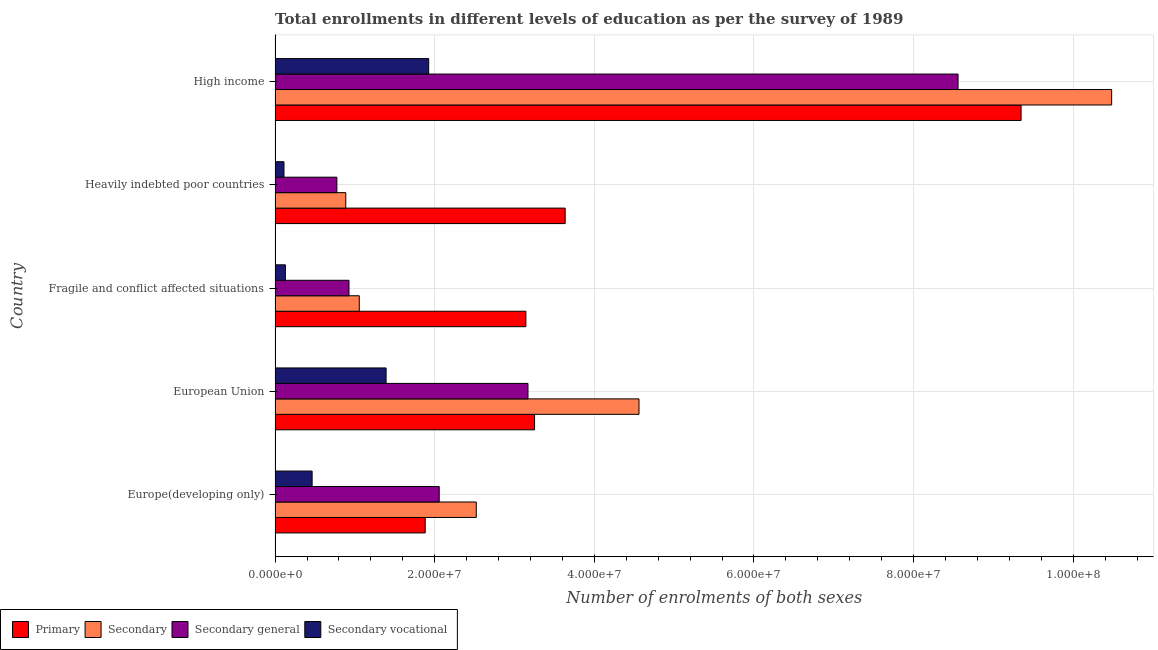How many different coloured bars are there?
Offer a terse response. 4. How many groups of bars are there?
Ensure brevity in your answer.  5. Are the number of bars on each tick of the Y-axis equal?
Keep it short and to the point. Yes. How many bars are there on the 4th tick from the top?
Your response must be concise. 4. How many bars are there on the 2nd tick from the bottom?
Ensure brevity in your answer.  4. What is the label of the 4th group of bars from the top?
Provide a short and direct response. European Union. In how many cases, is the number of bars for a given country not equal to the number of legend labels?
Give a very brief answer. 0. What is the number of enrolments in primary education in European Union?
Your response must be concise. 3.25e+07. Across all countries, what is the maximum number of enrolments in secondary education?
Ensure brevity in your answer.  1.05e+08. Across all countries, what is the minimum number of enrolments in secondary vocational education?
Your response must be concise. 1.12e+06. In which country was the number of enrolments in secondary general education maximum?
Give a very brief answer. High income. In which country was the number of enrolments in secondary education minimum?
Offer a very short reply. Heavily indebted poor countries. What is the total number of enrolments in secondary vocational education in the graph?
Give a very brief answer. 4.02e+07. What is the difference between the number of enrolments in secondary education in Europe(developing only) and that in High income?
Offer a very short reply. -7.96e+07. What is the difference between the number of enrolments in secondary general education in Heavily indebted poor countries and the number of enrolments in secondary education in European Union?
Make the answer very short. -3.79e+07. What is the average number of enrolments in primary education per country?
Your response must be concise. 4.25e+07. What is the difference between the number of enrolments in secondary vocational education and number of enrolments in secondary general education in Fragile and conflict affected situations?
Your response must be concise. -7.97e+06. In how many countries, is the number of enrolments in primary education greater than 84000000 ?
Ensure brevity in your answer.  1. What is the ratio of the number of enrolments in secondary education in Europe(developing only) to that in Heavily indebted poor countries?
Ensure brevity in your answer.  2.85. Is the number of enrolments in secondary vocational education in Fragile and conflict affected situations less than that in High income?
Keep it short and to the point. Yes. Is the difference between the number of enrolments in secondary general education in Europe(developing only) and Fragile and conflict affected situations greater than the difference between the number of enrolments in primary education in Europe(developing only) and Fragile and conflict affected situations?
Keep it short and to the point. Yes. What is the difference between the highest and the second highest number of enrolments in secondary general education?
Ensure brevity in your answer.  5.39e+07. What is the difference between the highest and the lowest number of enrolments in secondary general education?
Provide a succinct answer. 7.78e+07. Is the sum of the number of enrolments in primary education in Europe(developing only) and Heavily indebted poor countries greater than the maximum number of enrolments in secondary vocational education across all countries?
Your response must be concise. Yes. What does the 1st bar from the top in High income represents?
Ensure brevity in your answer.  Secondary vocational. What does the 3rd bar from the bottom in Europe(developing only) represents?
Provide a succinct answer. Secondary general. How many bars are there?
Give a very brief answer. 20. How many countries are there in the graph?
Your answer should be very brief. 5. Are the values on the major ticks of X-axis written in scientific E-notation?
Offer a terse response. Yes. Does the graph contain any zero values?
Offer a very short reply. No. How many legend labels are there?
Provide a succinct answer. 4. What is the title of the graph?
Your answer should be very brief. Total enrollments in different levels of education as per the survey of 1989. Does "Overall level" appear as one of the legend labels in the graph?
Keep it short and to the point. No. What is the label or title of the X-axis?
Your answer should be very brief. Number of enrolments of both sexes. What is the Number of enrolments of both sexes in Primary in Europe(developing only)?
Offer a very short reply. 1.88e+07. What is the Number of enrolments of both sexes of Secondary in Europe(developing only)?
Offer a very short reply. 2.52e+07. What is the Number of enrolments of both sexes of Secondary general in Europe(developing only)?
Give a very brief answer. 2.06e+07. What is the Number of enrolments of both sexes of Secondary vocational in Europe(developing only)?
Keep it short and to the point. 4.64e+06. What is the Number of enrolments of both sexes of Primary in European Union?
Keep it short and to the point. 3.25e+07. What is the Number of enrolments of both sexes in Secondary in European Union?
Make the answer very short. 4.56e+07. What is the Number of enrolments of both sexes in Secondary general in European Union?
Your answer should be very brief. 3.17e+07. What is the Number of enrolments of both sexes of Secondary vocational in European Union?
Your response must be concise. 1.39e+07. What is the Number of enrolments of both sexes of Primary in Fragile and conflict affected situations?
Your answer should be very brief. 3.14e+07. What is the Number of enrolments of both sexes of Secondary in Fragile and conflict affected situations?
Make the answer very short. 1.06e+07. What is the Number of enrolments of both sexes in Secondary general in Fragile and conflict affected situations?
Your answer should be very brief. 9.26e+06. What is the Number of enrolments of both sexes in Secondary vocational in Fragile and conflict affected situations?
Ensure brevity in your answer.  1.29e+06. What is the Number of enrolments of both sexes in Primary in Heavily indebted poor countries?
Offer a very short reply. 3.63e+07. What is the Number of enrolments of both sexes of Secondary in Heavily indebted poor countries?
Make the answer very short. 8.86e+06. What is the Number of enrolments of both sexes in Secondary general in Heavily indebted poor countries?
Provide a short and direct response. 7.74e+06. What is the Number of enrolments of both sexes in Secondary vocational in Heavily indebted poor countries?
Your answer should be compact. 1.12e+06. What is the Number of enrolments of both sexes in Primary in High income?
Provide a succinct answer. 9.35e+07. What is the Number of enrolments of both sexes in Secondary in High income?
Make the answer very short. 1.05e+08. What is the Number of enrolments of both sexes of Secondary general in High income?
Provide a short and direct response. 8.56e+07. What is the Number of enrolments of both sexes in Secondary vocational in High income?
Ensure brevity in your answer.  1.92e+07. Across all countries, what is the maximum Number of enrolments of both sexes of Primary?
Your answer should be very brief. 9.35e+07. Across all countries, what is the maximum Number of enrolments of both sexes in Secondary?
Your answer should be very brief. 1.05e+08. Across all countries, what is the maximum Number of enrolments of both sexes of Secondary general?
Ensure brevity in your answer.  8.56e+07. Across all countries, what is the maximum Number of enrolments of both sexes of Secondary vocational?
Offer a very short reply. 1.92e+07. Across all countries, what is the minimum Number of enrolments of both sexes in Primary?
Provide a short and direct response. 1.88e+07. Across all countries, what is the minimum Number of enrolments of both sexes of Secondary?
Offer a terse response. 8.86e+06. Across all countries, what is the minimum Number of enrolments of both sexes in Secondary general?
Your answer should be compact. 7.74e+06. Across all countries, what is the minimum Number of enrolments of both sexes of Secondary vocational?
Ensure brevity in your answer.  1.12e+06. What is the total Number of enrolments of both sexes in Primary in the graph?
Ensure brevity in your answer.  2.13e+08. What is the total Number of enrolments of both sexes in Secondary in the graph?
Provide a succinct answer. 1.95e+08. What is the total Number of enrolments of both sexes in Secondary general in the graph?
Offer a terse response. 1.55e+08. What is the total Number of enrolments of both sexes of Secondary vocational in the graph?
Your response must be concise. 4.02e+07. What is the difference between the Number of enrolments of both sexes of Primary in Europe(developing only) and that in European Union?
Your response must be concise. -1.37e+07. What is the difference between the Number of enrolments of both sexes of Secondary in Europe(developing only) and that in European Union?
Provide a short and direct response. -2.04e+07. What is the difference between the Number of enrolments of both sexes of Secondary general in Europe(developing only) and that in European Union?
Your answer should be compact. -1.11e+07. What is the difference between the Number of enrolments of both sexes of Secondary vocational in Europe(developing only) and that in European Union?
Your answer should be compact. -9.27e+06. What is the difference between the Number of enrolments of both sexes in Primary in Europe(developing only) and that in Fragile and conflict affected situations?
Your response must be concise. -1.26e+07. What is the difference between the Number of enrolments of both sexes in Secondary in Europe(developing only) and that in Fragile and conflict affected situations?
Your answer should be very brief. 1.47e+07. What is the difference between the Number of enrolments of both sexes of Secondary general in Europe(developing only) and that in Fragile and conflict affected situations?
Your answer should be compact. 1.13e+07. What is the difference between the Number of enrolments of both sexes of Secondary vocational in Europe(developing only) and that in Fragile and conflict affected situations?
Your answer should be compact. 3.35e+06. What is the difference between the Number of enrolments of both sexes of Primary in Europe(developing only) and that in Heavily indebted poor countries?
Ensure brevity in your answer.  -1.75e+07. What is the difference between the Number of enrolments of both sexes of Secondary in Europe(developing only) and that in Heavily indebted poor countries?
Offer a very short reply. 1.64e+07. What is the difference between the Number of enrolments of both sexes in Secondary general in Europe(developing only) and that in Heavily indebted poor countries?
Provide a short and direct response. 1.28e+07. What is the difference between the Number of enrolments of both sexes in Secondary vocational in Europe(developing only) and that in Heavily indebted poor countries?
Ensure brevity in your answer.  3.53e+06. What is the difference between the Number of enrolments of both sexes of Primary in Europe(developing only) and that in High income?
Make the answer very short. -7.47e+07. What is the difference between the Number of enrolments of both sexes of Secondary in Europe(developing only) and that in High income?
Provide a short and direct response. -7.96e+07. What is the difference between the Number of enrolments of both sexes in Secondary general in Europe(developing only) and that in High income?
Offer a terse response. -6.50e+07. What is the difference between the Number of enrolments of both sexes of Secondary vocational in Europe(developing only) and that in High income?
Keep it short and to the point. -1.46e+07. What is the difference between the Number of enrolments of both sexes of Primary in European Union and that in Fragile and conflict affected situations?
Your response must be concise. 1.09e+06. What is the difference between the Number of enrolments of both sexes of Secondary in European Union and that in Fragile and conflict affected situations?
Keep it short and to the point. 3.50e+07. What is the difference between the Number of enrolments of both sexes in Secondary general in European Union and that in Fragile and conflict affected situations?
Offer a very short reply. 2.24e+07. What is the difference between the Number of enrolments of both sexes of Secondary vocational in European Union and that in Fragile and conflict affected situations?
Provide a succinct answer. 1.26e+07. What is the difference between the Number of enrolments of both sexes in Primary in European Union and that in Heavily indebted poor countries?
Offer a very short reply. -3.84e+06. What is the difference between the Number of enrolments of both sexes in Secondary in European Union and that in Heavily indebted poor countries?
Provide a succinct answer. 3.67e+07. What is the difference between the Number of enrolments of both sexes in Secondary general in European Union and that in Heavily indebted poor countries?
Keep it short and to the point. 2.39e+07. What is the difference between the Number of enrolments of both sexes of Secondary vocational in European Union and that in Heavily indebted poor countries?
Your response must be concise. 1.28e+07. What is the difference between the Number of enrolments of both sexes in Primary in European Union and that in High income?
Give a very brief answer. -6.10e+07. What is the difference between the Number of enrolments of both sexes in Secondary in European Union and that in High income?
Provide a short and direct response. -5.92e+07. What is the difference between the Number of enrolments of both sexes of Secondary general in European Union and that in High income?
Ensure brevity in your answer.  -5.39e+07. What is the difference between the Number of enrolments of both sexes of Secondary vocational in European Union and that in High income?
Provide a succinct answer. -5.34e+06. What is the difference between the Number of enrolments of both sexes in Primary in Fragile and conflict affected situations and that in Heavily indebted poor countries?
Provide a succinct answer. -4.92e+06. What is the difference between the Number of enrolments of both sexes of Secondary in Fragile and conflict affected situations and that in Heavily indebted poor countries?
Provide a short and direct response. 1.69e+06. What is the difference between the Number of enrolments of both sexes of Secondary general in Fragile and conflict affected situations and that in Heavily indebted poor countries?
Your response must be concise. 1.52e+06. What is the difference between the Number of enrolments of both sexes of Secondary vocational in Fragile and conflict affected situations and that in Heavily indebted poor countries?
Provide a succinct answer. 1.76e+05. What is the difference between the Number of enrolments of both sexes of Primary in Fragile and conflict affected situations and that in High income?
Provide a short and direct response. -6.20e+07. What is the difference between the Number of enrolments of both sexes in Secondary in Fragile and conflict affected situations and that in High income?
Ensure brevity in your answer.  -9.43e+07. What is the difference between the Number of enrolments of both sexes in Secondary general in Fragile and conflict affected situations and that in High income?
Give a very brief answer. -7.63e+07. What is the difference between the Number of enrolments of both sexes of Secondary vocational in Fragile and conflict affected situations and that in High income?
Make the answer very short. -1.80e+07. What is the difference between the Number of enrolments of both sexes of Primary in Heavily indebted poor countries and that in High income?
Ensure brevity in your answer.  -5.71e+07. What is the difference between the Number of enrolments of both sexes in Secondary in Heavily indebted poor countries and that in High income?
Provide a succinct answer. -9.60e+07. What is the difference between the Number of enrolments of both sexes in Secondary general in Heavily indebted poor countries and that in High income?
Ensure brevity in your answer.  -7.78e+07. What is the difference between the Number of enrolments of both sexes in Secondary vocational in Heavily indebted poor countries and that in High income?
Provide a succinct answer. -1.81e+07. What is the difference between the Number of enrolments of both sexes of Primary in Europe(developing only) and the Number of enrolments of both sexes of Secondary in European Union?
Your answer should be compact. -2.68e+07. What is the difference between the Number of enrolments of both sexes in Primary in Europe(developing only) and the Number of enrolments of both sexes in Secondary general in European Union?
Offer a very short reply. -1.29e+07. What is the difference between the Number of enrolments of both sexes in Primary in Europe(developing only) and the Number of enrolments of both sexes in Secondary vocational in European Union?
Make the answer very short. 4.90e+06. What is the difference between the Number of enrolments of both sexes of Secondary in Europe(developing only) and the Number of enrolments of both sexes of Secondary general in European Union?
Make the answer very short. -6.48e+06. What is the difference between the Number of enrolments of both sexes in Secondary in Europe(developing only) and the Number of enrolments of both sexes in Secondary vocational in European Union?
Ensure brevity in your answer.  1.13e+07. What is the difference between the Number of enrolments of both sexes of Secondary general in Europe(developing only) and the Number of enrolments of both sexes of Secondary vocational in European Union?
Provide a short and direct response. 6.66e+06. What is the difference between the Number of enrolments of both sexes in Primary in Europe(developing only) and the Number of enrolments of both sexes in Secondary in Fragile and conflict affected situations?
Make the answer very short. 8.26e+06. What is the difference between the Number of enrolments of both sexes in Primary in Europe(developing only) and the Number of enrolments of both sexes in Secondary general in Fragile and conflict affected situations?
Your response must be concise. 9.55e+06. What is the difference between the Number of enrolments of both sexes of Primary in Europe(developing only) and the Number of enrolments of both sexes of Secondary vocational in Fragile and conflict affected situations?
Your answer should be compact. 1.75e+07. What is the difference between the Number of enrolments of both sexes of Secondary in Europe(developing only) and the Number of enrolments of both sexes of Secondary general in Fragile and conflict affected situations?
Your response must be concise. 1.59e+07. What is the difference between the Number of enrolments of both sexes of Secondary in Europe(developing only) and the Number of enrolments of both sexes of Secondary vocational in Fragile and conflict affected situations?
Offer a terse response. 2.39e+07. What is the difference between the Number of enrolments of both sexes of Secondary general in Europe(developing only) and the Number of enrolments of both sexes of Secondary vocational in Fragile and conflict affected situations?
Provide a short and direct response. 1.93e+07. What is the difference between the Number of enrolments of both sexes of Primary in Europe(developing only) and the Number of enrolments of both sexes of Secondary in Heavily indebted poor countries?
Provide a succinct answer. 9.95e+06. What is the difference between the Number of enrolments of both sexes in Primary in Europe(developing only) and the Number of enrolments of both sexes in Secondary general in Heavily indebted poor countries?
Offer a terse response. 1.11e+07. What is the difference between the Number of enrolments of both sexes in Primary in Europe(developing only) and the Number of enrolments of both sexes in Secondary vocational in Heavily indebted poor countries?
Give a very brief answer. 1.77e+07. What is the difference between the Number of enrolments of both sexes of Secondary in Europe(developing only) and the Number of enrolments of both sexes of Secondary general in Heavily indebted poor countries?
Keep it short and to the point. 1.75e+07. What is the difference between the Number of enrolments of both sexes of Secondary in Europe(developing only) and the Number of enrolments of both sexes of Secondary vocational in Heavily indebted poor countries?
Provide a short and direct response. 2.41e+07. What is the difference between the Number of enrolments of both sexes of Secondary general in Europe(developing only) and the Number of enrolments of both sexes of Secondary vocational in Heavily indebted poor countries?
Keep it short and to the point. 1.95e+07. What is the difference between the Number of enrolments of both sexes of Primary in Europe(developing only) and the Number of enrolments of both sexes of Secondary in High income?
Ensure brevity in your answer.  -8.60e+07. What is the difference between the Number of enrolments of both sexes in Primary in Europe(developing only) and the Number of enrolments of both sexes in Secondary general in High income?
Your answer should be very brief. -6.68e+07. What is the difference between the Number of enrolments of both sexes of Primary in Europe(developing only) and the Number of enrolments of both sexes of Secondary vocational in High income?
Make the answer very short. -4.38e+05. What is the difference between the Number of enrolments of both sexes in Secondary in Europe(developing only) and the Number of enrolments of both sexes in Secondary general in High income?
Your answer should be compact. -6.04e+07. What is the difference between the Number of enrolments of both sexes of Secondary in Europe(developing only) and the Number of enrolments of both sexes of Secondary vocational in High income?
Give a very brief answer. 5.96e+06. What is the difference between the Number of enrolments of both sexes in Secondary general in Europe(developing only) and the Number of enrolments of both sexes in Secondary vocational in High income?
Make the answer very short. 1.32e+06. What is the difference between the Number of enrolments of both sexes in Primary in European Union and the Number of enrolments of both sexes in Secondary in Fragile and conflict affected situations?
Offer a very short reply. 2.20e+07. What is the difference between the Number of enrolments of both sexes in Primary in European Union and the Number of enrolments of both sexes in Secondary general in Fragile and conflict affected situations?
Offer a very short reply. 2.33e+07. What is the difference between the Number of enrolments of both sexes in Primary in European Union and the Number of enrolments of both sexes in Secondary vocational in Fragile and conflict affected situations?
Your response must be concise. 3.12e+07. What is the difference between the Number of enrolments of both sexes of Secondary in European Union and the Number of enrolments of both sexes of Secondary general in Fragile and conflict affected situations?
Offer a terse response. 3.63e+07. What is the difference between the Number of enrolments of both sexes of Secondary in European Union and the Number of enrolments of both sexes of Secondary vocational in Fragile and conflict affected situations?
Your answer should be compact. 4.43e+07. What is the difference between the Number of enrolments of both sexes of Secondary general in European Union and the Number of enrolments of both sexes of Secondary vocational in Fragile and conflict affected situations?
Offer a very short reply. 3.04e+07. What is the difference between the Number of enrolments of both sexes of Primary in European Union and the Number of enrolments of both sexes of Secondary in Heavily indebted poor countries?
Keep it short and to the point. 2.37e+07. What is the difference between the Number of enrolments of both sexes in Primary in European Union and the Number of enrolments of both sexes in Secondary general in Heavily indebted poor countries?
Offer a terse response. 2.48e+07. What is the difference between the Number of enrolments of both sexes of Primary in European Union and the Number of enrolments of both sexes of Secondary vocational in Heavily indebted poor countries?
Make the answer very short. 3.14e+07. What is the difference between the Number of enrolments of both sexes of Secondary in European Union and the Number of enrolments of both sexes of Secondary general in Heavily indebted poor countries?
Provide a succinct answer. 3.79e+07. What is the difference between the Number of enrolments of both sexes in Secondary in European Union and the Number of enrolments of both sexes in Secondary vocational in Heavily indebted poor countries?
Your response must be concise. 4.45e+07. What is the difference between the Number of enrolments of both sexes of Secondary general in European Union and the Number of enrolments of both sexes of Secondary vocational in Heavily indebted poor countries?
Provide a short and direct response. 3.06e+07. What is the difference between the Number of enrolments of both sexes of Primary in European Union and the Number of enrolments of both sexes of Secondary in High income?
Provide a succinct answer. -7.23e+07. What is the difference between the Number of enrolments of both sexes of Primary in European Union and the Number of enrolments of both sexes of Secondary general in High income?
Provide a succinct answer. -5.31e+07. What is the difference between the Number of enrolments of both sexes in Primary in European Union and the Number of enrolments of both sexes in Secondary vocational in High income?
Provide a short and direct response. 1.33e+07. What is the difference between the Number of enrolments of both sexes of Secondary in European Union and the Number of enrolments of both sexes of Secondary general in High income?
Offer a very short reply. -4.00e+07. What is the difference between the Number of enrolments of both sexes of Secondary in European Union and the Number of enrolments of both sexes of Secondary vocational in High income?
Your response must be concise. 2.63e+07. What is the difference between the Number of enrolments of both sexes of Secondary general in European Union and the Number of enrolments of both sexes of Secondary vocational in High income?
Keep it short and to the point. 1.24e+07. What is the difference between the Number of enrolments of both sexes in Primary in Fragile and conflict affected situations and the Number of enrolments of both sexes in Secondary in Heavily indebted poor countries?
Make the answer very short. 2.26e+07. What is the difference between the Number of enrolments of both sexes in Primary in Fragile and conflict affected situations and the Number of enrolments of both sexes in Secondary general in Heavily indebted poor countries?
Your answer should be compact. 2.37e+07. What is the difference between the Number of enrolments of both sexes of Primary in Fragile and conflict affected situations and the Number of enrolments of both sexes of Secondary vocational in Heavily indebted poor countries?
Offer a very short reply. 3.03e+07. What is the difference between the Number of enrolments of both sexes of Secondary in Fragile and conflict affected situations and the Number of enrolments of both sexes of Secondary general in Heavily indebted poor countries?
Ensure brevity in your answer.  2.81e+06. What is the difference between the Number of enrolments of both sexes in Secondary in Fragile and conflict affected situations and the Number of enrolments of both sexes in Secondary vocational in Heavily indebted poor countries?
Ensure brevity in your answer.  9.43e+06. What is the difference between the Number of enrolments of both sexes of Secondary general in Fragile and conflict affected situations and the Number of enrolments of both sexes of Secondary vocational in Heavily indebted poor countries?
Your answer should be compact. 8.14e+06. What is the difference between the Number of enrolments of both sexes of Primary in Fragile and conflict affected situations and the Number of enrolments of both sexes of Secondary in High income?
Your answer should be very brief. -7.34e+07. What is the difference between the Number of enrolments of both sexes of Primary in Fragile and conflict affected situations and the Number of enrolments of both sexes of Secondary general in High income?
Offer a terse response. -5.41e+07. What is the difference between the Number of enrolments of both sexes in Primary in Fragile and conflict affected situations and the Number of enrolments of both sexes in Secondary vocational in High income?
Give a very brief answer. 1.22e+07. What is the difference between the Number of enrolments of both sexes of Secondary in Fragile and conflict affected situations and the Number of enrolments of both sexes of Secondary general in High income?
Your response must be concise. -7.50e+07. What is the difference between the Number of enrolments of both sexes in Secondary in Fragile and conflict affected situations and the Number of enrolments of both sexes in Secondary vocational in High income?
Provide a short and direct response. -8.70e+06. What is the difference between the Number of enrolments of both sexes in Secondary general in Fragile and conflict affected situations and the Number of enrolments of both sexes in Secondary vocational in High income?
Offer a very short reply. -9.99e+06. What is the difference between the Number of enrolments of both sexes in Primary in Heavily indebted poor countries and the Number of enrolments of both sexes in Secondary in High income?
Give a very brief answer. -6.85e+07. What is the difference between the Number of enrolments of both sexes of Primary in Heavily indebted poor countries and the Number of enrolments of both sexes of Secondary general in High income?
Offer a terse response. -4.92e+07. What is the difference between the Number of enrolments of both sexes of Primary in Heavily indebted poor countries and the Number of enrolments of both sexes of Secondary vocational in High income?
Provide a succinct answer. 1.71e+07. What is the difference between the Number of enrolments of both sexes of Secondary in Heavily indebted poor countries and the Number of enrolments of both sexes of Secondary general in High income?
Offer a very short reply. -7.67e+07. What is the difference between the Number of enrolments of both sexes of Secondary in Heavily indebted poor countries and the Number of enrolments of both sexes of Secondary vocational in High income?
Your response must be concise. -1.04e+07. What is the difference between the Number of enrolments of both sexes in Secondary general in Heavily indebted poor countries and the Number of enrolments of both sexes in Secondary vocational in High income?
Keep it short and to the point. -1.15e+07. What is the average Number of enrolments of both sexes in Primary per country?
Make the answer very short. 4.25e+07. What is the average Number of enrolments of both sexes of Secondary per country?
Your answer should be very brief. 3.90e+07. What is the average Number of enrolments of both sexes of Secondary general per country?
Ensure brevity in your answer.  3.10e+07. What is the average Number of enrolments of both sexes of Secondary vocational per country?
Offer a terse response. 8.04e+06. What is the difference between the Number of enrolments of both sexes of Primary and Number of enrolments of both sexes of Secondary in Europe(developing only)?
Your response must be concise. -6.40e+06. What is the difference between the Number of enrolments of both sexes in Primary and Number of enrolments of both sexes in Secondary general in Europe(developing only)?
Your response must be concise. -1.76e+06. What is the difference between the Number of enrolments of both sexes of Primary and Number of enrolments of both sexes of Secondary vocational in Europe(developing only)?
Your answer should be very brief. 1.42e+07. What is the difference between the Number of enrolments of both sexes in Secondary and Number of enrolments of both sexes in Secondary general in Europe(developing only)?
Provide a succinct answer. 4.64e+06. What is the difference between the Number of enrolments of both sexes in Secondary and Number of enrolments of both sexes in Secondary vocational in Europe(developing only)?
Offer a terse response. 2.06e+07. What is the difference between the Number of enrolments of both sexes in Secondary general and Number of enrolments of both sexes in Secondary vocational in Europe(developing only)?
Provide a short and direct response. 1.59e+07. What is the difference between the Number of enrolments of both sexes in Primary and Number of enrolments of both sexes in Secondary in European Union?
Keep it short and to the point. -1.31e+07. What is the difference between the Number of enrolments of both sexes in Primary and Number of enrolments of both sexes in Secondary general in European Union?
Make the answer very short. 8.24e+05. What is the difference between the Number of enrolments of both sexes of Primary and Number of enrolments of both sexes of Secondary vocational in European Union?
Ensure brevity in your answer.  1.86e+07. What is the difference between the Number of enrolments of both sexes of Secondary and Number of enrolments of both sexes of Secondary general in European Union?
Make the answer very short. 1.39e+07. What is the difference between the Number of enrolments of both sexes in Secondary and Number of enrolments of both sexes in Secondary vocational in European Union?
Your answer should be very brief. 3.17e+07. What is the difference between the Number of enrolments of both sexes in Secondary general and Number of enrolments of both sexes in Secondary vocational in European Union?
Your response must be concise. 1.78e+07. What is the difference between the Number of enrolments of both sexes in Primary and Number of enrolments of both sexes in Secondary in Fragile and conflict affected situations?
Keep it short and to the point. 2.09e+07. What is the difference between the Number of enrolments of both sexes of Primary and Number of enrolments of both sexes of Secondary general in Fragile and conflict affected situations?
Your response must be concise. 2.22e+07. What is the difference between the Number of enrolments of both sexes in Primary and Number of enrolments of both sexes in Secondary vocational in Fragile and conflict affected situations?
Offer a very short reply. 3.01e+07. What is the difference between the Number of enrolments of both sexes in Secondary and Number of enrolments of both sexes in Secondary general in Fragile and conflict affected situations?
Your answer should be compact. 1.29e+06. What is the difference between the Number of enrolments of both sexes in Secondary and Number of enrolments of both sexes in Secondary vocational in Fragile and conflict affected situations?
Offer a very short reply. 9.26e+06. What is the difference between the Number of enrolments of both sexes in Secondary general and Number of enrolments of both sexes in Secondary vocational in Fragile and conflict affected situations?
Offer a very short reply. 7.97e+06. What is the difference between the Number of enrolments of both sexes of Primary and Number of enrolments of both sexes of Secondary in Heavily indebted poor countries?
Ensure brevity in your answer.  2.75e+07. What is the difference between the Number of enrolments of both sexes of Primary and Number of enrolments of both sexes of Secondary general in Heavily indebted poor countries?
Your answer should be compact. 2.86e+07. What is the difference between the Number of enrolments of both sexes in Primary and Number of enrolments of both sexes in Secondary vocational in Heavily indebted poor countries?
Keep it short and to the point. 3.52e+07. What is the difference between the Number of enrolments of both sexes in Secondary and Number of enrolments of both sexes in Secondary general in Heavily indebted poor countries?
Your answer should be very brief. 1.12e+06. What is the difference between the Number of enrolments of both sexes in Secondary and Number of enrolments of both sexes in Secondary vocational in Heavily indebted poor countries?
Make the answer very short. 7.74e+06. What is the difference between the Number of enrolments of both sexes in Secondary general and Number of enrolments of both sexes in Secondary vocational in Heavily indebted poor countries?
Your response must be concise. 6.63e+06. What is the difference between the Number of enrolments of both sexes of Primary and Number of enrolments of both sexes of Secondary in High income?
Your answer should be compact. -1.14e+07. What is the difference between the Number of enrolments of both sexes of Primary and Number of enrolments of both sexes of Secondary general in High income?
Ensure brevity in your answer.  7.90e+06. What is the difference between the Number of enrolments of both sexes in Primary and Number of enrolments of both sexes in Secondary vocational in High income?
Offer a terse response. 7.42e+07. What is the difference between the Number of enrolments of both sexes in Secondary and Number of enrolments of both sexes in Secondary general in High income?
Your answer should be very brief. 1.92e+07. What is the difference between the Number of enrolments of both sexes of Secondary and Number of enrolments of both sexes of Secondary vocational in High income?
Give a very brief answer. 8.56e+07. What is the difference between the Number of enrolments of both sexes of Secondary general and Number of enrolments of both sexes of Secondary vocational in High income?
Your response must be concise. 6.63e+07. What is the ratio of the Number of enrolments of both sexes of Primary in Europe(developing only) to that in European Union?
Offer a very short reply. 0.58. What is the ratio of the Number of enrolments of both sexes of Secondary in Europe(developing only) to that in European Union?
Make the answer very short. 0.55. What is the ratio of the Number of enrolments of both sexes of Secondary general in Europe(developing only) to that in European Union?
Make the answer very short. 0.65. What is the ratio of the Number of enrolments of both sexes of Secondary vocational in Europe(developing only) to that in European Union?
Offer a terse response. 0.33. What is the ratio of the Number of enrolments of both sexes in Primary in Europe(developing only) to that in Fragile and conflict affected situations?
Give a very brief answer. 0.6. What is the ratio of the Number of enrolments of both sexes of Secondary in Europe(developing only) to that in Fragile and conflict affected situations?
Your answer should be compact. 2.39. What is the ratio of the Number of enrolments of both sexes in Secondary general in Europe(developing only) to that in Fragile and conflict affected situations?
Give a very brief answer. 2.22. What is the ratio of the Number of enrolments of both sexes in Secondary vocational in Europe(developing only) to that in Fragile and conflict affected situations?
Offer a terse response. 3.59. What is the ratio of the Number of enrolments of both sexes in Primary in Europe(developing only) to that in Heavily indebted poor countries?
Offer a terse response. 0.52. What is the ratio of the Number of enrolments of both sexes of Secondary in Europe(developing only) to that in Heavily indebted poor countries?
Provide a short and direct response. 2.85. What is the ratio of the Number of enrolments of both sexes of Secondary general in Europe(developing only) to that in Heavily indebted poor countries?
Ensure brevity in your answer.  2.66. What is the ratio of the Number of enrolments of both sexes in Secondary vocational in Europe(developing only) to that in Heavily indebted poor countries?
Offer a very short reply. 4.16. What is the ratio of the Number of enrolments of both sexes of Primary in Europe(developing only) to that in High income?
Your answer should be very brief. 0.2. What is the ratio of the Number of enrolments of both sexes of Secondary in Europe(developing only) to that in High income?
Your answer should be very brief. 0.24. What is the ratio of the Number of enrolments of both sexes of Secondary general in Europe(developing only) to that in High income?
Give a very brief answer. 0.24. What is the ratio of the Number of enrolments of both sexes in Secondary vocational in Europe(developing only) to that in High income?
Give a very brief answer. 0.24. What is the ratio of the Number of enrolments of both sexes of Primary in European Union to that in Fragile and conflict affected situations?
Keep it short and to the point. 1.03. What is the ratio of the Number of enrolments of both sexes in Secondary in European Union to that in Fragile and conflict affected situations?
Your response must be concise. 4.32. What is the ratio of the Number of enrolments of both sexes in Secondary general in European Union to that in Fragile and conflict affected situations?
Give a very brief answer. 3.42. What is the ratio of the Number of enrolments of both sexes in Secondary vocational in European Union to that in Fragile and conflict affected situations?
Your answer should be very brief. 10.77. What is the ratio of the Number of enrolments of both sexes of Primary in European Union to that in Heavily indebted poor countries?
Make the answer very short. 0.89. What is the ratio of the Number of enrolments of both sexes in Secondary in European Union to that in Heavily indebted poor countries?
Your response must be concise. 5.15. What is the ratio of the Number of enrolments of both sexes in Secondary general in European Union to that in Heavily indebted poor countries?
Your response must be concise. 4.09. What is the ratio of the Number of enrolments of both sexes of Secondary vocational in European Union to that in Heavily indebted poor countries?
Your answer should be very brief. 12.47. What is the ratio of the Number of enrolments of both sexes of Primary in European Union to that in High income?
Keep it short and to the point. 0.35. What is the ratio of the Number of enrolments of both sexes in Secondary in European Union to that in High income?
Offer a very short reply. 0.43. What is the ratio of the Number of enrolments of both sexes of Secondary general in European Union to that in High income?
Give a very brief answer. 0.37. What is the ratio of the Number of enrolments of both sexes of Secondary vocational in European Union to that in High income?
Keep it short and to the point. 0.72. What is the ratio of the Number of enrolments of both sexes in Primary in Fragile and conflict affected situations to that in Heavily indebted poor countries?
Your answer should be compact. 0.86. What is the ratio of the Number of enrolments of both sexes of Secondary in Fragile and conflict affected situations to that in Heavily indebted poor countries?
Give a very brief answer. 1.19. What is the ratio of the Number of enrolments of both sexes of Secondary general in Fragile and conflict affected situations to that in Heavily indebted poor countries?
Your answer should be compact. 1.2. What is the ratio of the Number of enrolments of both sexes in Secondary vocational in Fragile and conflict affected situations to that in Heavily indebted poor countries?
Offer a terse response. 1.16. What is the ratio of the Number of enrolments of both sexes in Primary in Fragile and conflict affected situations to that in High income?
Ensure brevity in your answer.  0.34. What is the ratio of the Number of enrolments of both sexes of Secondary in Fragile and conflict affected situations to that in High income?
Offer a terse response. 0.1. What is the ratio of the Number of enrolments of both sexes in Secondary general in Fragile and conflict affected situations to that in High income?
Your answer should be compact. 0.11. What is the ratio of the Number of enrolments of both sexes of Secondary vocational in Fragile and conflict affected situations to that in High income?
Offer a very short reply. 0.07. What is the ratio of the Number of enrolments of both sexes of Primary in Heavily indebted poor countries to that in High income?
Offer a very short reply. 0.39. What is the ratio of the Number of enrolments of both sexes in Secondary in Heavily indebted poor countries to that in High income?
Provide a succinct answer. 0.08. What is the ratio of the Number of enrolments of both sexes in Secondary general in Heavily indebted poor countries to that in High income?
Give a very brief answer. 0.09. What is the ratio of the Number of enrolments of both sexes in Secondary vocational in Heavily indebted poor countries to that in High income?
Ensure brevity in your answer.  0.06. What is the difference between the highest and the second highest Number of enrolments of both sexes of Primary?
Give a very brief answer. 5.71e+07. What is the difference between the highest and the second highest Number of enrolments of both sexes of Secondary?
Your response must be concise. 5.92e+07. What is the difference between the highest and the second highest Number of enrolments of both sexes of Secondary general?
Provide a short and direct response. 5.39e+07. What is the difference between the highest and the second highest Number of enrolments of both sexes in Secondary vocational?
Offer a terse response. 5.34e+06. What is the difference between the highest and the lowest Number of enrolments of both sexes of Primary?
Your response must be concise. 7.47e+07. What is the difference between the highest and the lowest Number of enrolments of both sexes in Secondary?
Your answer should be very brief. 9.60e+07. What is the difference between the highest and the lowest Number of enrolments of both sexes in Secondary general?
Offer a very short reply. 7.78e+07. What is the difference between the highest and the lowest Number of enrolments of both sexes in Secondary vocational?
Offer a very short reply. 1.81e+07. 